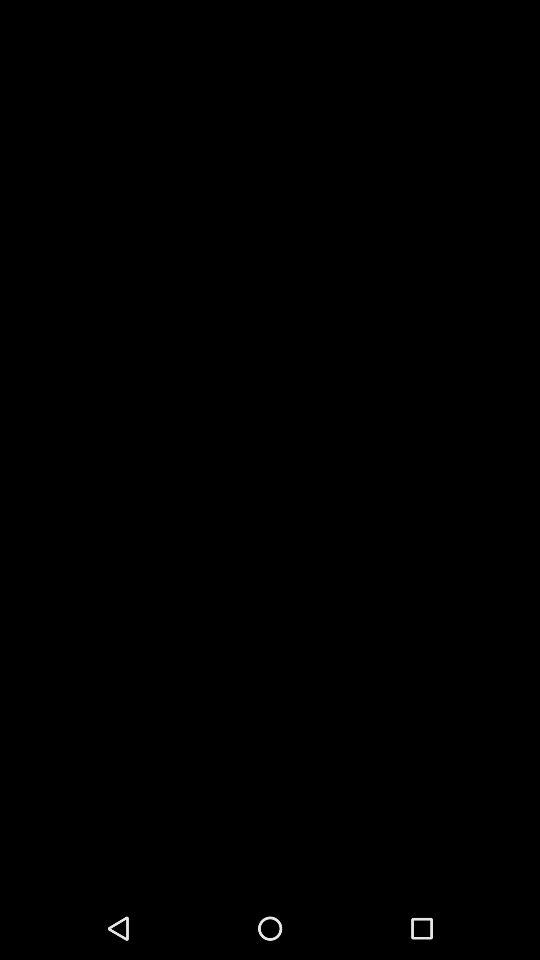What is the selected option? The selected option is "Viewer". 